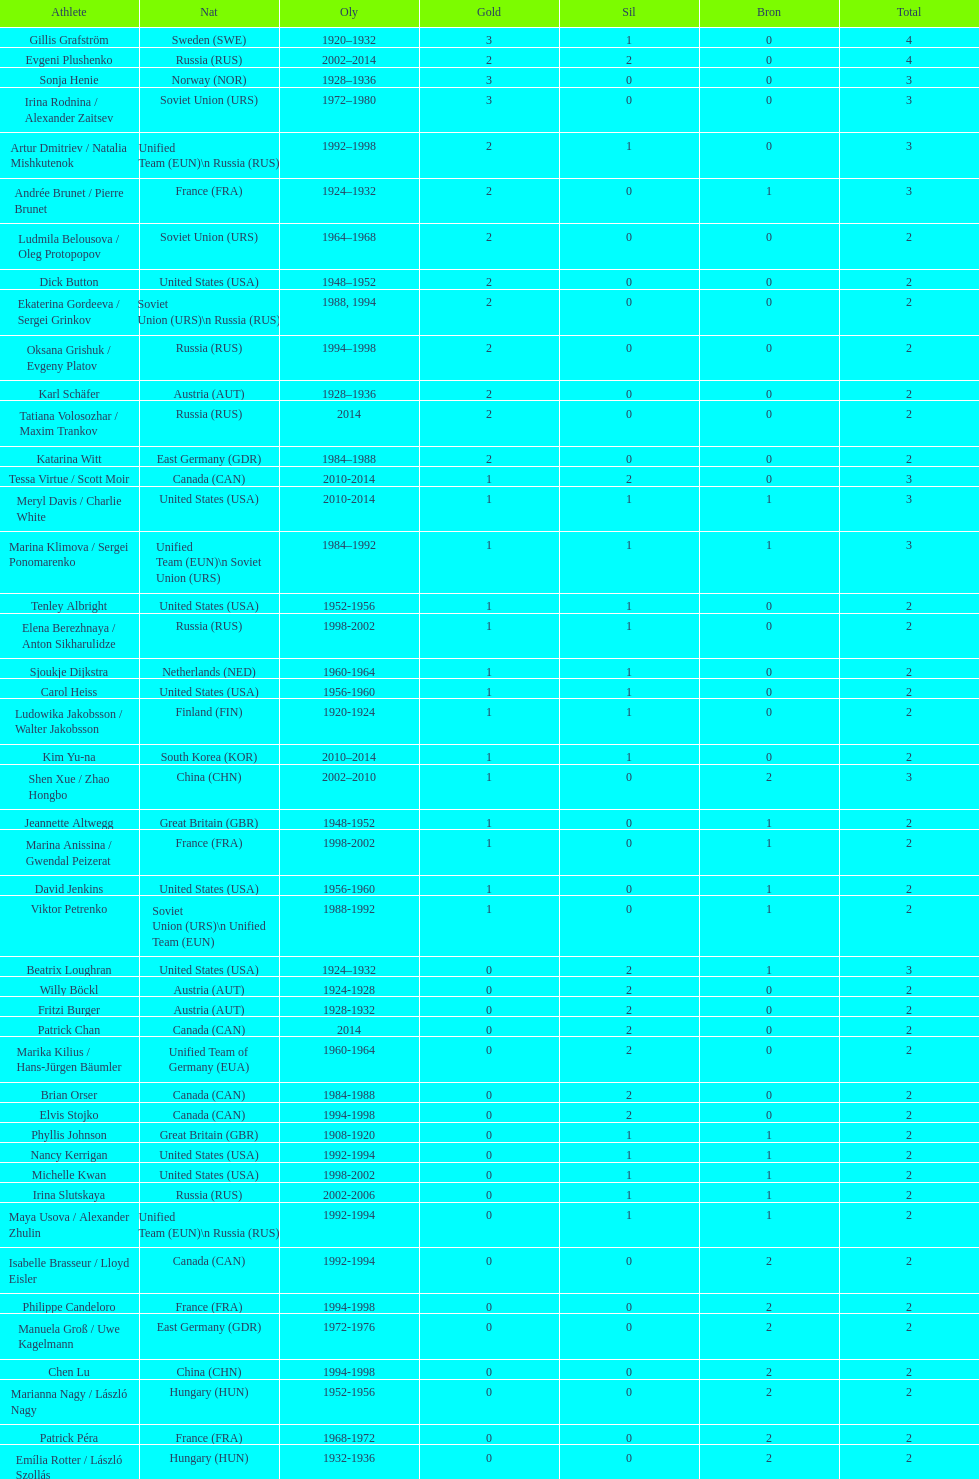How many silver medals did evgeni plushenko get? 2. 